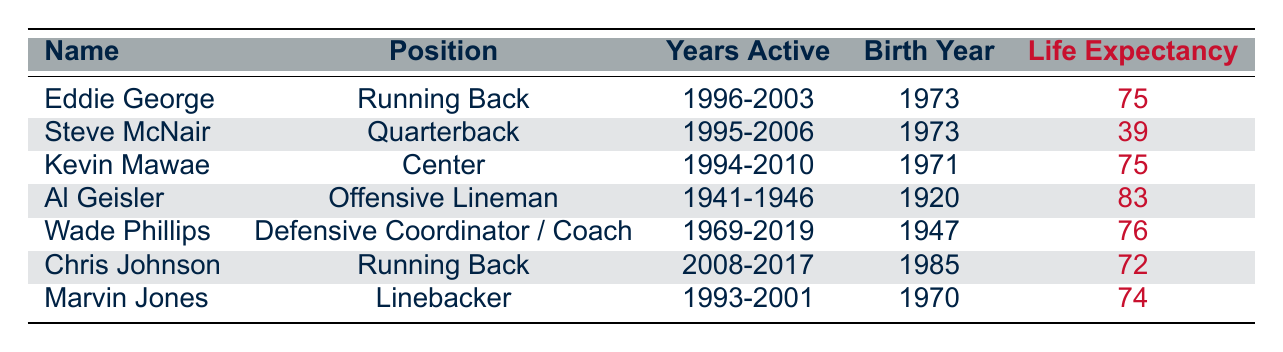What is the life expectancy estimate of Eddie George? The table shows the row for Eddie George, where the life expectancy estimate is clearly listed as 75.
Answer: 75 Which player has the lowest life expectancy estimate? By comparing the life expectancy estimates in the table, Steve McNair has the lowest estimate at 39 years.
Answer: Steve McNair How many players have a life expectancy estimate of 75 or higher? The players with life expectancy estimates of 75 or higher are Eddie George (75), Kevin Mawae (75), and Al Geisler (83). This totals 3 players.
Answer: 3 What is the average life expectancy estimate of all players listed in the table? The life expectancy estimates are 75, 39, 75, 83, 76, 72, and 74. Summing these gives 75 + 39 + 75 + 83 + 76 + 72 + 74 = 494. There are 7 players, so the average is 494 / 7 = 70.57, which is approximately 71.
Answer: 71 Is there a player from the 1970s who has a life expectancy estimate below 75? Yes, Steve McNair was born in 1973 and has a life expectancy estimate of 39, which is below 75.
Answer: Yes Who was active the longest in their NFL career among the listed players? Wade Phillips was active from 1969 to 2019, which totals 50 years, the longest among the players listed.
Answer: Wade Phillips How many players were born in the 1970s? The players born in the 1970s are Eddie George (1973), Steve McNair (1973), Kevin Mawae (1971), Marvin Jones (1970), and Chris Johnson (1985). Excluding Chris Johnson, there are 4 players born in the 1970s.
Answer: 4 Is the life expectancy estimate of Wade Phillips greater than the average life expectancy estimate of all players? Since the average life expectancy calculated earlier is about 71, and Wade Phillips' life expectancy estimate is 76, it is indeed greater.
Answer: Yes What is the difference in life expectancy between Al Geisler and Steve McNair? Al Geisler has a life expectancy estimate of 83, while Steve McNair has 39; the difference is 83 - 39 = 44.
Answer: 44 